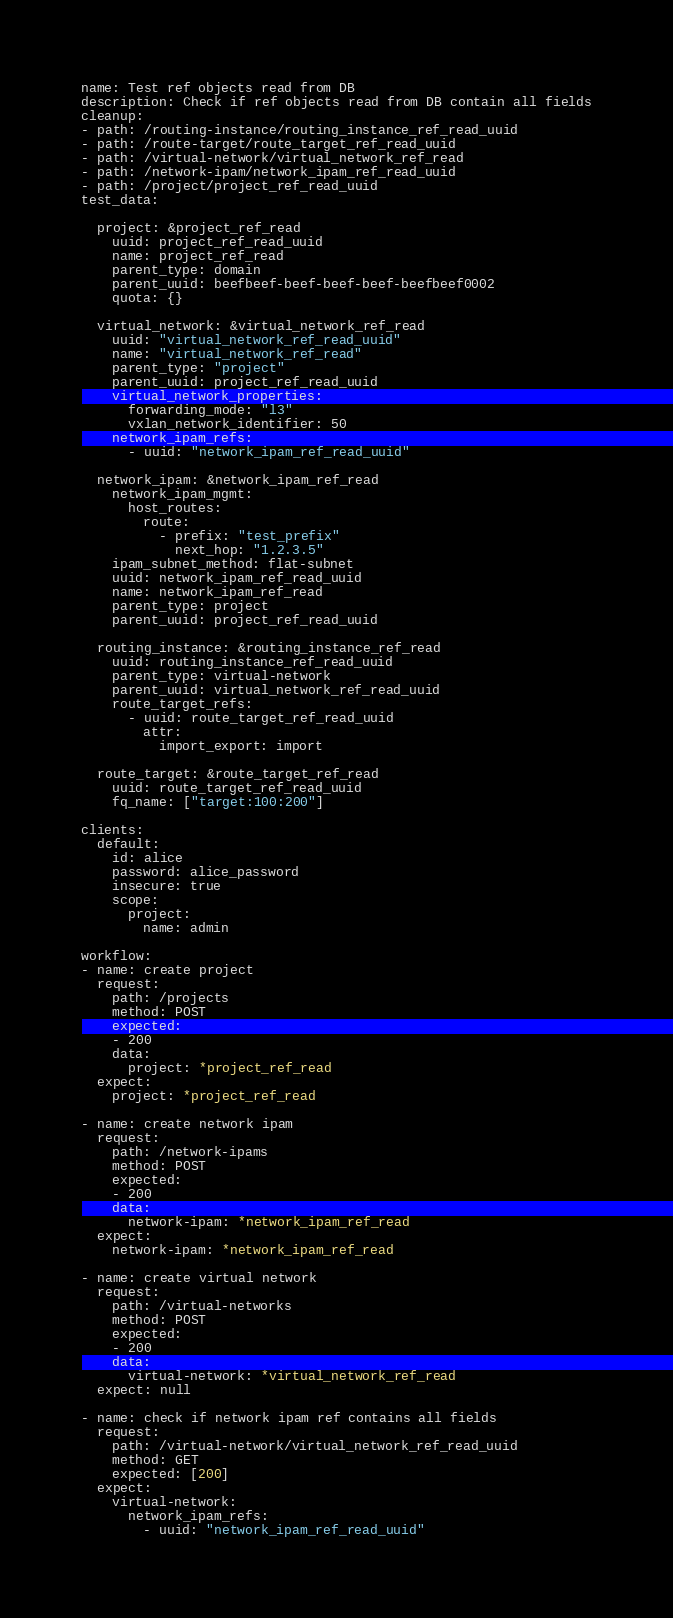Convert code to text. <code><loc_0><loc_0><loc_500><loc_500><_YAML_>name: Test ref objects read from DB
description: Check if ref objects read from DB contain all fields
cleanup:
- path: /routing-instance/routing_instance_ref_read_uuid
- path: /route-target/route_target_ref_read_uuid
- path: /virtual-network/virtual_network_ref_read
- path: /network-ipam/network_ipam_ref_read_uuid
- path: /project/project_ref_read_uuid
test_data:

  project: &project_ref_read
    uuid: project_ref_read_uuid
    name: project_ref_read
    parent_type: domain
    parent_uuid: beefbeef-beef-beef-beef-beefbeef0002
    quota: {}

  virtual_network: &virtual_network_ref_read
    uuid: "virtual_network_ref_read_uuid"
    name: "virtual_network_ref_read"
    parent_type: "project"
    parent_uuid: project_ref_read_uuid
    virtual_network_properties:
      forwarding_mode: "l3"
      vxlan_network_identifier: 50
    network_ipam_refs:
      - uuid: "network_ipam_ref_read_uuid"

  network_ipam: &network_ipam_ref_read
    network_ipam_mgmt:
      host_routes:
        route:
          - prefix: "test_prefix"
            next_hop: "1.2.3.5"
    ipam_subnet_method: flat-subnet
    uuid: network_ipam_ref_read_uuid
    name: network_ipam_ref_read
    parent_type: project
    parent_uuid: project_ref_read_uuid

  routing_instance: &routing_instance_ref_read
    uuid: routing_instance_ref_read_uuid
    parent_type: virtual-network
    parent_uuid: virtual_network_ref_read_uuid
    route_target_refs:
      - uuid: route_target_ref_read_uuid
        attr:
          import_export: import

  route_target: &route_target_ref_read
    uuid: route_target_ref_read_uuid
    fq_name: ["target:100:200"]

clients:
  default:
    id: alice
    password: alice_password
    insecure: true
    scope:
      project:
        name: admin

workflow:
- name: create project
  request:
    path: /projects
    method: POST
    expected:
    - 200
    data:
      project: *project_ref_read
  expect:
    project: *project_ref_read

- name: create network ipam
  request:
    path: /network-ipams
    method: POST
    expected:
    - 200
    data:
      network-ipam: *network_ipam_ref_read
  expect:
    network-ipam: *network_ipam_ref_read

- name: create virtual network
  request:
    path: /virtual-networks
    method: POST
    expected:
    - 200
    data:
      virtual-network: *virtual_network_ref_read
  expect: null

- name: check if network ipam ref contains all fields
  request:
    path: /virtual-network/virtual_network_ref_read_uuid
    method: GET
    expected: [200]
  expect:
    virtual-network:
      network_ipam_refs:
        - uuid: "network_ipam_ref_read_uuid"</code> 